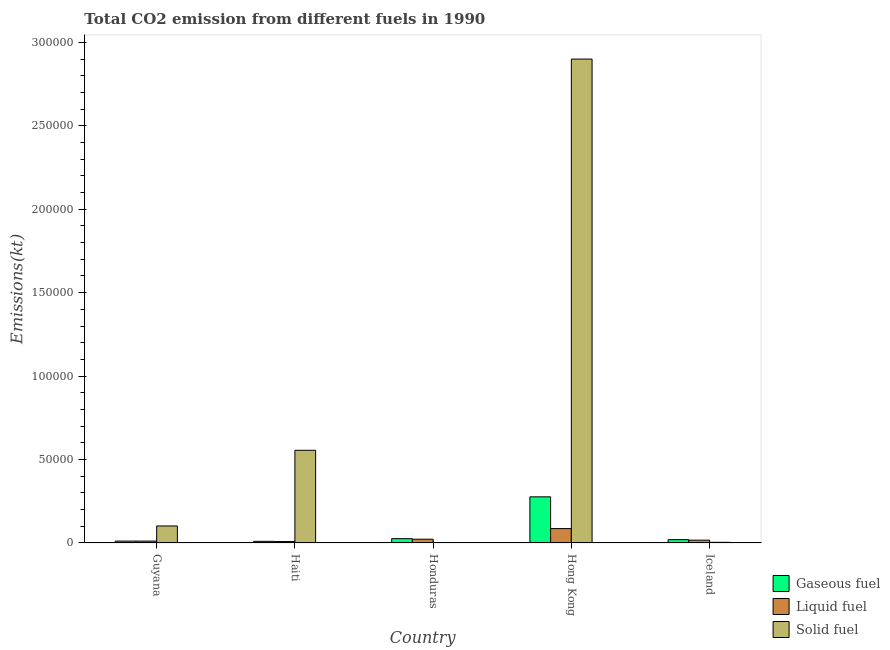How many groups of bars are there?
Provide a succinct answer. 5. Are the number of bars per tick equal to the number of legend labels?
Provide a short and direct response. Yes. How many bars are there on the 5th tick from the right?
Keep it short and to the point. 3. In how many cases, is the number of bars for a given country not equal to the number of legend labels?
Offer a terse response. 0. What is the amount of co2 emissions from gaseous fuel in Hong Kong?
Make the answer very short. 2.77e+04. Across all countries, what is the maximum amount of co2 emissions from gaseous fuel?
Your response must be concise. 2.77e+04. Across all countries, what is the minimum amount of co2 emissions from liquid fuel?
Make the answer very short. 861.75. In which country was the amount of co2 emissions from solid fuel maximum?
Your response must be concise. Hong Kong. In which country was the amount of co2 emissions from liquid fuel minimum?
Provide a succinct answer. Haiti. What is the total amount of co2 emissions from gaseous fuel in the graph?
Ensure brevity in your answer.  3.44e+04. What is the difference between the amount of co2 emissions from liquid fuel in Haiti and that in Iceland?
Offer a very short reply. -832.41. What is the difference between the amount of co2 emissions from solid fuel in Haiti and the amount of co2 emissions from gaseous fuel in Iceland?
Provide a short and direct response. 5.36e+04. What is the average amount of co2 emissions from gaseous fuel per country?
Ensure brevity in your answer.  6877.09. What is the difference between the amount of co2 emissions from liquid fuel and amount of co2 emissions from gaseous fuel in Haiti?
Make the answer very short. -132.01. What is the ratio of the amount of co2 emissions from gaseous fuel in Honduras to that in Hong Kong?
Offer a terse response. 0.09. Is the amount of co2 emissions from gaseous fuel in Guyana less than that in Iceland?
Keep it short and to the point. Yes. Is the difference between the amount of co2 emissions from solid fuel in Guyana and Iceland greater than the difference between the amount of co2 emissions from liquid fuel in Guyana and Iceland?
Your response must be concise. Yes. What is the difference between the highest and the second highest amount of co2 emissions from gaseous fuel?
Provide a succinct answer. 2.51e+04. What is the difference between the highest and the lowest amount of co2 emissions from gaseous fuel?
Offer a very short reply. 2.67e+04. In how many countries, is the amount of co2 emissions from liquid fuel greater than the average amount of co2 emissions from liquid fuel taken over all countries?
Give a very brief answer. 1. Is the sum of the amount of co2 emissions from gaseous fuel in Hong Kong and Iceland greater than the maximum amount of co2 emissions from liquid fuel across all countries?
Your response must be concise. Yes. What does the 2nd bar from the left in Guyana represents?
Your answer should be very brief. Liquid fuel. What does the 2nd bar from the right in Haiti represents?
Make the answer very short. Liquid fuel. Is it the case that in every country, the sum of the amount of co2 emissions from gaseous fuel and amount of co2 emissions from liquid fuel is greater than the amount of co2 emissions from solid fuel?
Give a very brief answer. No. Are all the bars in the graph horizontal?
Provide a short and direct response. No. How many countries are there in the graph?
Your response must be concise. 5. Are the values on the major ticks of Y-axis written in scientific E-notation?
Your answer should be compact. No. How are the legend labels stacked?
Your answer should be very brief. Vertical. What is the title of the graph?
Offer a very short reply. Total CO2 emission from different fuels in 1990. What is the label or title of the Y-axis?
Offer a terse response. Emissions(kt). What is the Emissions(kt) of Gaseous fuel in Guyana?
Make the answer very short. 1140.44. What is the Emissions(kt) in Liquid fuel in Guyana?
Provide a short and direct response. 1140.44. What is the Emissions(kt) of Solid fuel in Guyana?
Offer a very short reply. 1.02e+04. What is the Emissions(kt) in Gaseous fuel in Haiti?
Keep it short and to the point. 993.76. What is the Emissions(kt) of Liquid fuel in Haiti?
Give a very brief answer. 861.75. What is the Emissions(kt) of Solid fuel in Haiti?
Offer a terse response. 5.56e+04. What is the Emissions(kt) in Gaseous fuel in Honduras?
Make the answer very short. 2592.57. What is the Emissions(kt) in Liquid fuel in Honduras?
Provide a short and direct response. 2266.21. What is the Emissions(kt) of Solid fuel in Honduras?
Offer a terse response. 139.35. What is the Emissions(kt) in Gaseous fuel in Hong Kong?
Ensure brevity in your answer.  2.77e+04. What is the Emissions(kt) in Liquid fuel in Hong Kong?
Make the answer very short. 8632.12. What is the Emissions(kt) of Solid fuel in Hong Kong?
Your response must be concise. 2.90e+05. What is the Emissions(kt) of Gaseous fuel in Iceland?
Your answer should be very brief. 1998.52. What is the Emissions(kt) of Liquid fuel in Iceland?
Give a very brief answer. 1694.15. What is the Emissions(kt) in Solid fuel in Iceland?
Ensure brevity in your answer.  403.37. Across all countries, what is the maximum Emissions(kt) of Gaseous fuel?
Your response must be concise. 2.77e+04. Across all countries, what is the maximum Emissions(kt) of Liquid fuel?
Your answer should be very brief. 8632.12. Across all countries, what is the maximum Emissions(kt) of Solid fuel?
Your answer should be compact. 2.90e+05. Across all countries, what is the minimum Emissions(kt) in Gaseous fuel?
Make the answer very short. 993.76. Across all countries, what is the minimum Emissions(kt) of Liquid fuel?
Offer a very short reply. 861.75. Across all countries, what is the minimum Emissions(kt) of Solid fuel?
Your response must be concise. 139.35. What is the total Emissions(kt) of Gaseous fuel in the graph?
Offer a very short reply. 3.44e+04. What is the total Emissions(kt) of Liquid fuel in the graph?
Provide a short and direct response. 1.46e+04. What is the total Emissions(kt) of Solid fuel in the graph?
Provide a short and direct response. 3.56e+05. What is the difference between the Emissions(kt) of Gaseous fuel in Guyana and that in Haiti?
Your answer should be very brief. 146.68. What is the difference between the Emissions(kt) of Liquid fuel in Guyana and that in Haiti?
Provide a short and direct response. 278.69. What is the difference between the Emissions(kt) of Solid fuel in Guyana and that in Haiti?
Offer a terse response. -4.53e+04. What is the difference between the Emissions(kt) in Gaseous fuel in Guyana and that in Honduras?
Your answer should be compact. -1452.13. What is the difference between the Emissions(kt) in Liquid fuel in Guyana and that in Honduras?
Your answer should be very brief. -1125.77. What is the difference between the Emissions(kt) of Solid fuel in Guyana and that in Honduras?
Your answer should be compact. 1.01e+04. What is the difference between the Emissions(kt) of Gaseous fuel in Guyana and that in Hong Kong?
Give a very brief answer. -2.65e+04. What is the difference between the Emissions(kt) in Liquid fuel in Guyana and that in Hong Kong?
Offer a very short reply. -7491.68. What is the difference between the Emissions(kt) of Solid fuel in Guyana and that in Hong Kong?
Give a very brief answer. -2.80e+05. What is the difference between the Emissions(kt) of Gaseous fuel in Guyana and that in Iceland?
Offer a terse response. -858.08. What is the difference between the Emissions(kt) in Liquid fuel in Guyana and that in Iceland?
Your answer should be very brief. -553.72. What is the difference between the Emissions(kt) in Solid fuel in Guyana and that in Iceland?
Keep it short and to the point. 9798.22. What is the difference between the Emissions(kt) of Gaseous fuel in Haiti and that in Honduras?
Provide a short and direct response. -1598.81. What is the difference between the Emissions(kt) of Liquid fuel in Haiti and that in Honduras?
Give a very brief answer. -1404.46. What is the difference between the Emissions(kt) in Solid fuel in Haiti and that in Honduras?
Offer a terse response. 5.54e+04. What is the difference between the Emissions(kt) of Gaseous fuel in Haiti and that in Hong Kong?
Provide a short and direct response. -2.67e+04. What is the difference between the Emissions(kt) in Liquid fuel in Haiti and that in Hong Kong?
Provide a succinct answer. -7770.37. What is the difference between the Emissions(kt) of Solid fuel in Haiti and that in Hong Kong?
Keep it short and to the point. -2.34e+05. What is the difference between the Emissions(kt) of Gaseous fuel in Haiti and that in Iceland?
Offer a very short reply. -1004.76. What is the difference between the Emissions(kt) in Liquid fuel in Haiti and that in Iceland?
Your response must be concise. -832.41. What is the difference between the Emissions(kt) of Solid fuel in Haiti and that in Iceland?
Make the answer very short. 5.51e+04. What is the difference between the Emissions(kt) in Gaseous fuel in Honduras and that in Hong Kong?
Offer a terse response. -2.51e+04. What is the difference between the Emissions(kt) of Liquid fuel in Honduras and that in Hong Kong?
Provide a succinct answer. -6365.91. What is the difference between the Emissions(kt) in Solid fuel in Honduras and that in Hong Kong?
Your response must be concise. -2.90e+05. What is the difference between the Emissions(kt) in Gaseous fuel in Honduras and that in Iceland?
Make the answer very short. 594.05. What is the difference between the Emissions(kt) in Liquid fuel in Honduras and that in Iceland?
Keep it short and to the point. 572.05. What is the difference between the Emissions(kt) of Solid fuel in Honduras and that in Iceland?
Offer a very short reply. -264.02. What is the difference between the Emissions(kt) of Gaseous fuel in Hong Kong and that in Iceland?
Provide a short and direct response. 2.57e+04. What is the difference between the Emissions(kt) of Liquid fuel in Hong Kong and that in Iceland?
Make the answer very short. 6937.96. What is the difference between the Emissions(kt) of Solid fuel in Hong Kong and that in Iceland?
Your answer should be compact. 2.90e+05. What is the difference between the Emissions(kt) in Gaseous fuel in Guyana and the Emissions(kt) in Liquid fuel in Haiti?
Your answer should be compact. 278.69. What is the difference between the Emissions(kt) of Gaseous fuel in Guyana and the Emissions(kt) of Solid fuel in Haiti?
Give a very brief answer. -5.44e+04. What is the difference between the Emissions(kt) in Liquid fuel in Guyana and the Emissions(kt) in Solid fuel in Haiti?
Offer a very short reply. -5.44e+04. What is the difference between the Emissions(kt) in Gaseous fuel in Guyana and the Emissions(kt) in Liquid fuel in Honduras?
Make the answer very short. -1125.77. What is the difference between the Emissions(kt) of Gaseous fuel in Guyana and the Emissions(kt) of Solid fuel in Honduras?
Ensure brevity in your answer.  1001.09. What is the difference between the Emissions(kt) in Liquid fuel in Guyana and the Emissions(kt) in Solid fuel in Honduras?
Your answer should be very brief. 1001.09. What is the difference between the Emissions(kt) in Gaseous fuel in Guyana and the Emissions(kt) in Liquid fuel in Hong Kong?
Your response must be concise. -7491.68. What is the difference between the Emissions(kt) of Gaseous fuel in Guyana and the Emissions(kt) of Solid fuel in Hong Kong?
Your answer should be very brief. -2.89e+05. What is the difference between the Emissions(kt) in Liquid fuel in Guyana and the Emissions(kt) in Solid fuel in Hong Kong?
Your answer should be very brief. -2.89e+05. What is the difference between the Emissions(kt) in Gaseous fuel in Guyana and the Emissions(kt) in Liquid fuel in Iceland?
Provide a succinct answer. -553.72. What is the difference between the Emissions(kt) in Gaseous fuel in Guyana and the Emissions(kt) in Solid fuel in Iceland?
Offer a terse response. 737.07. What is the difference between the Emissions(kt) of Liquid fuel in Guyana and the Emissions(kt) of Solid fuel in Iceland?
Give a very brief answer. 737.07. What is the difference between the Emissions(kt) of Gaseous fuel in Haiti and the Emissions(kt) of Liquid fuel in Honduras?
Your response must be concise. -1272.45. What is the difference between the Emissions(kt) in Gaseous fuel in Haiti and the Emissions(kt) in Solid fuel in Honduras?
Keep it short and to the point. 854.41. What is the difference between the Emissions(kt) in Liquid fuel in Haiti and the Emissions(kt) in Solid fuel in Honduras?
Keep it short and to the point. 722.4. What is the difference between the Emissions(kt) in Gaseous fuel in Haiti and the Emissions(kt) in Liquid fuel in Hong Kong?
Make the answer very short. -7638.36. What is the difference between the Emissions(kt) of Gaseous fuel in Haiti and the Emissions(kt) of Solid fuel in Hong Kong?
Give a very brief answer. -2.89e+05. What is the difference between the Emissions(kt) in Liquid fuel in Haiti and the Emissions(kt) in Solid fuel in Hong Kong?
Offer a terse response. -2.89e+05. What is the difference between the Emissions(kt) in Gaseous fuel in Haiti and the Emissions(kt) in Liquid fuel in Iceland?
Your response must be concise. -700.4. What is the difference between the Emissions(kt) of Gaseous fuel in Haiti and the Emissions(kt) of Solid fuel in Iceland?
Keep it short and to the point. 590.39. What is the difference between the Emissions(kt) in Liquid fuel in Haiti and the Emissions(kt) in Solid fuel in Iceland?
Keep it short and to the point. 458.38. What is the difference between the Emissions(kt) in Gaseous fuel in Honduras and the Emissions(kt) in Liquid fuel in Hong Kong?
Offer a very short reply. -6039.55. What is the difference between the Emissions(kt) in Gaseous fuel in Honduras and the Emissions(kt) in Solid fuel in Hong Kong?
Keep it short and to the point. -2.87e+05. What is the difference between the Emissions(kt) in Liquid fuel in Honduras and the Emissions(kt) in Solid fuel in Hong Kong?
Make the answer very short. -2.88e+05. What is the difference between the Emissions(kt) of Gaseous fuel in Honduras and the Emissions(kt) of Liquid fuel in Iceland?
Make the answer very short. 898.41. What is the difference between the Emissions(kt) in Gaseous fuel in Honduras and the Emissions(kt) in Solid fuel in Iceland?
Offer a very short reply. 2189.2. What is the difference between the Emissions(kt) of Liquid fuel in Honduras and the Emissions(kt) of Solid fuel in Iceland?
Keep it short and to the point. 1862.84. What is the difference between the Emissions(kt) of Gaseous fuel in Hong Kong and the Emissions(kt) of Liquid fuel in Iceland?
Your answer should be very brief. 2.60e+04. What is the difference between the Emissions(kt) in Gaseous fuel in Hong Kong and the Emissions(kt) in Solid fuel in Iceland?
Keep it short and to the point. 2.73e+04. What is the difference between the Emissions(kt) in Liquid fuel in Hong Kong and the Emissions(kt) in Solid fuel in Iceland?
Provide a short and direct response. 8228.75. What is the average Emissions(kt) in Gaseous fuel per country?
Provide a short and direct response. 6877.09. What is the average Emissions(kt) in Liquid fuel per country?
Your response must be concise. 2918.93. What is the average Emissions(kt) in Solid fuel per country?
Your response must be concise. 7.13e+04. What is the difference between the Emissions(kt) of Gaseous fuel and Emissions(kt) of Liquid fuel in Guyana?
Ensure brevity in your answer.  0. What is the difference between the Emissions(kt) of Gaseous fuel and Emissions(kt) of Solid fuel in Guyana?
Keep it short and to the point. -9061.16. What is the difference between the Emissions(kt) in Liquid fuel and Emissions(kt) in Solid fuel in Guyana?
Offer a terse response. -9061.16. What is the difference between the Emissions(kt) of Gaseous fuel and Emissions(kt) of Liquid fuel in Haiti?
Your answer should be very brief. 132.01. What is the difference between the Emissions(kt) of Gaseous fuel and Emissions(kt) of Solid fuel in Haiti?
Give a very brief answer. -5.46e+04. What is the difference between the Emissions(kt) in Liquid fuel and Emissions(kt) in Solid fuel in Haiti?
Offer a terse response. -5.47e+04. What is the difference between the Emissions(kt) in Gaseous fuel and Emissions(kt) in Liquid fuel in Honduras?
Provide a short and direct response. 326.36. What is the difference between the Emissions(kt) in Gaseous fuel and Emissions(kt) in Solid fuel in Honduras?
Provide a short and direct response. 2453.22. What is the difference between the Emissions(kt) of Liquid fuel and Emissions(kt) of Solid fuel in Honduras?
Offer a very short reply. 2126.86. What is the difference between the Emissions(kt) in Gaseous fuel and Emissions(kt) in Liquid fuel in Hong Kong?
Ensure brevity in your answer.  1.90e+04. What is the difference between the Emissions(kt) in Gaseous fuel and Emissions(kt) in Solid fuel in Hong Kong?
Your answer should be compact. -2.62e+05. What is the difference between the Emissions(kt) in Liquid fuel and Emissions(kt) in Solid fuel in Hong Kong?
Keep it short and to the point. -2.81e+05. What is the difference between the Emissions(kt) in Gaseous fuel and Emissions(kt) in Liquid fuel in Iceland?
Provide a succinct answer. 304.36. What is the difference between the Emissions(kt) in Gaseous fuel and Emissions(kt) in Solid fuel in Iceland?
Provide a short and direct response. 1595.14. What is the difference between the Emissions(kt) in Liquid fuel and Emissions(kt) in Solid fuel in Iceland?
Offer a very short reply. 1290.78. What is the ratio of the Emissions(kt) of Gaseous fuel in Guyana to that in Haiti?
Ensure brevity in your answer.  1.15. What is the ratio of the Emissions(kt) of Liquid fuel in Guyana to that in Haiti?
Your answer should be compact. 1.32. What is the ratio of the Emissions(kt) in Solid fuel in Guyana to that in Haiti?
Provide a succinct answer. 0.18. What is the ratio of the Emissions(kt) of Gaseous fuel in Guyana to that in Honduras?
Your answer should be compact. 0.44. What is the ratio of the Emissions(kt) in Liquid fuel in Guyana to that in Honduras?
Ensure brevity in your answer.  0.5. What is the ratio of the Emissions(kt) in Solid fuel in Guyana to that in Honduras?
Offer a very short reply. 73.21. What is the ratio of the Emissions(kt) in Gaseous fuel in Guyana to that in Hong Kong?
Provide a short and direct response. 0.04. What is the ratio of the Emissions(kt) of Liquid fuel in Guyana to that in Hong Kong?
Offer a very short reply. 0.13. What is the ratio of the Emissions(kt) of Solid fuel in Guyana to that in Hong Kong?
Your answer should be very brief. 0.04. What is the ratio of the Emissions(kt) in Gaseous fuel in Guyana to that in Iceland?
Provide a short and direct response. 0.57. What is the ratio of the Emissions(kt) in Liquid fuel in Guyana to that in Iceland?
Offer a terse response. 0.67. What is the ratio of the Emissions(kt) of Solid fuel in Guyana to that in Iceland?
Make the answer very short. 25.29. What is the ratio of the Emissions(kt) in Gaseous fuel in Haiti to that in Honduras?
Your response must be concise. 0.38. What is the ratio of the Emissions(kt) of Liquid fuel in Haiti to that in Honduras?
Provide a short and direct response. 0.38. What is the ratio of the Emissions(kt) of Solid fuel in Haiti to that in Honduras?
Make the answer very short. 398.66. What is the ratio of the Emissions(kt) in Gaseous fuel in Haiti to that in Hong Kong?
Ensure brevity in your answer.  0.04. What is the ratio of the Emissions(kt) of Liquid fuel in Haiti to that in Hong Kong?
Give a very brief answer. 0.1. What is the ratio of the Emissions(kt) of Solid fuel in Haiti to that in Hong Kong?
Make the answer very short. 0.19. What is the ratio of the Emissions(kt) in Gaseous fuel in Haiti to that in Iceland?
Give a very brief answer. 0.5. What is the ratio of the Emissions(kt) in Liquid fuel in Haiti to that in Iceland?
Offer a terse response. 0.51. What is the ratio of the Emissions(kt) of Solid fuel in Haiti to that in Iceland?
Your answer should be compact. 137.72. What is the ratio of the Emissions(kt) in Gaseous fuel in Honduras to that in Hong Kong?
Your answer should be compact. 0.09. What is the ratio of the Emissions(kt) in Liquid fuel in Honduras to that in Hong Kong?
Offer a terse response. 0.26. What is the ratio of the Emissions(kt) in Solid fuel in Honduras to that in Hong Kong?
Offer a terse response. 0. What is the ratio of the Emissions(kt) of Gaseous fuel in Honduras to that in Iceland?
Keep it short and to the point. 1.3. What is the ratio of the Emissions(kt) of Liquid fuel in Honduras to that in Iceland?
Give a very brief answer. 1.34. What is the ratio of the Emissions(kt) of Solid fuel in Honduras to that in Iceland?
Ensure brevity in your answer.  0.35. What is the ratio of the Emissions(kt) in Gaseous fuel in Hong Kong to that in Iceland?
Ensure brevity in your answer.  13.84. What is the ratio of the Emissions(kt) in Liquid fuel in Hong Kong to that in Iceland?
Your answer should be compact. 5.1. What is the ratio of the Emissions(kt) of Solid fuel in Hong Kong to that in Iceland?
Your answer should be compact. 718.93. What is the difference between the highest and the second highest Emissions(kt) in Gaseous fuel?
Ensure brevity in your answer.  2.51e+04. What is the difference between the highest and the second highest Emissions(kt) of Liquid fuel?
Provide a succinct answer. 6365.91. What is the difference between the highest and the second highest Emissions(kt) of Solid fuel?
Offer a very short reply. 2.34e+05. What is the difference between the highest and the lowest Emissions(kt) in Gaseous fuel?
Your answer should be compact. 2.67e+04. What is the difference between the highest and the lowest Emissions(kt) of Liquid fuel?
Your answer should be very brief. 7770.37. What is the difference between the highest and the lowest Emissions(kt) of Solid fuel?
Provide a short and direct response. 2.90e+05. 